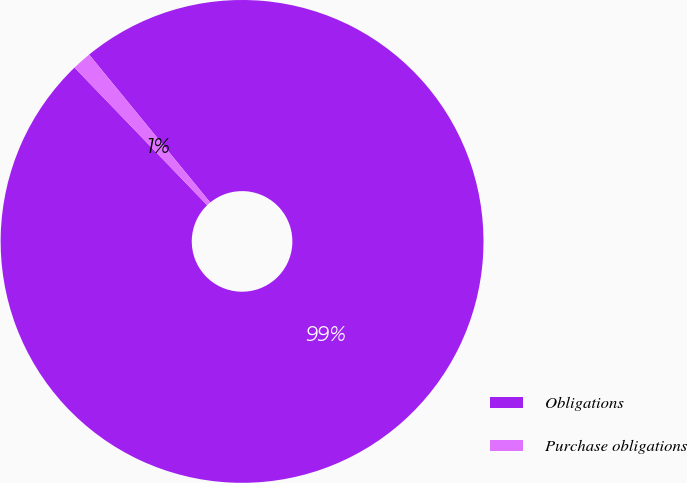<chart> <loc_0><loc_0><loc_500><loc_500><pie_chart><fcel>Obligations<fcel>Purchase obligations<nl><fcel>98.71%<fcel>1.29%<nl></chart> 